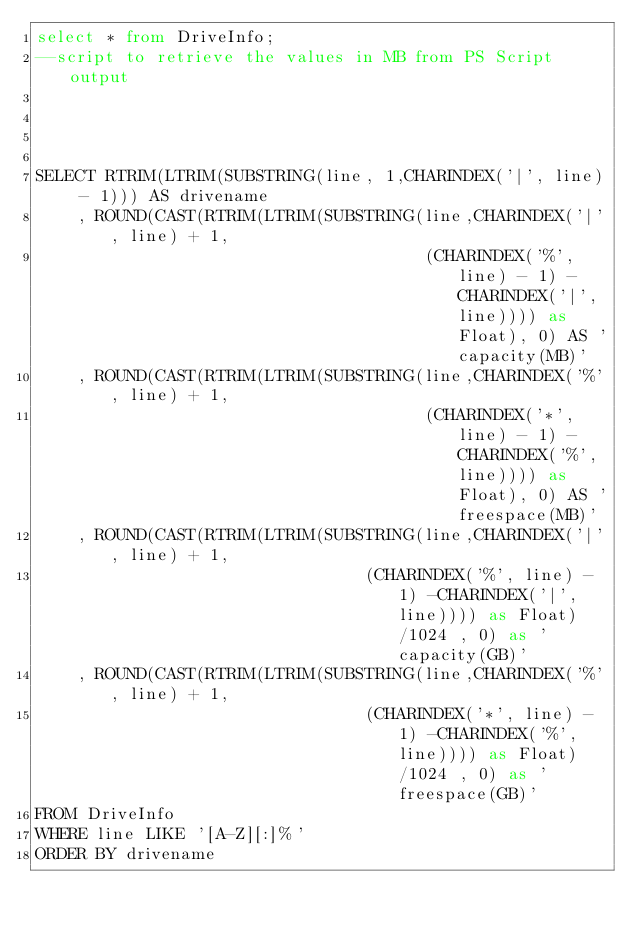Convert code to text. <code><loc_0><loc_0><loc_500><loc_500><_SQL_>select * from DriveInfo;
--script to retrieve the values in MB from PS Script output




SELECT RTRIM(LTRIM(SUBSTRING(line, 1,CHARINDEX('|', line) - 1))) AS drivename
    , ROUND(CAST(RTRIM(LTRIM(SUBSTRING(line,CHARINDEX('|', line) + 1,
                                       (CHARINDEX('%', line) - 1) -CHARINDEX('|', line)))) as Float), 0) AS 'capacity(MB)'
    , ROUND(CAST(RTRIM(LTRIM(SUBSTRING(line,CHARINDEX('%', line) + 1,
                                       (CHARINDEX('*', line) - 1) -CHARINDEX('%', line)))) as Float), 0) AS 'freespace(MB)'
    , ROUND(CAST(RTRIM(LTRIM(SUBSTRING(line,CHARINDEX('|', line) + 1,
                                 (CHARINDEX('%', line) - 1) -CHARINDEX('|', line)))) as Float)/1024 , 0) as 'capacity(GB)'
    , ROUND(CAST(RTRIM(LTRIM(SUBSTRING(line,CHARINDEX('%', line) + 1,
                                 (CHARINDEX('*', line) - 1) -CHARINDEX('%', line)))) as Float)/1024 , 0) as 'freespace(GB)'
FROM DriveInfo
WHERE line LIKE '[A-Z][:]%'
ORDER BY drivename</code> 